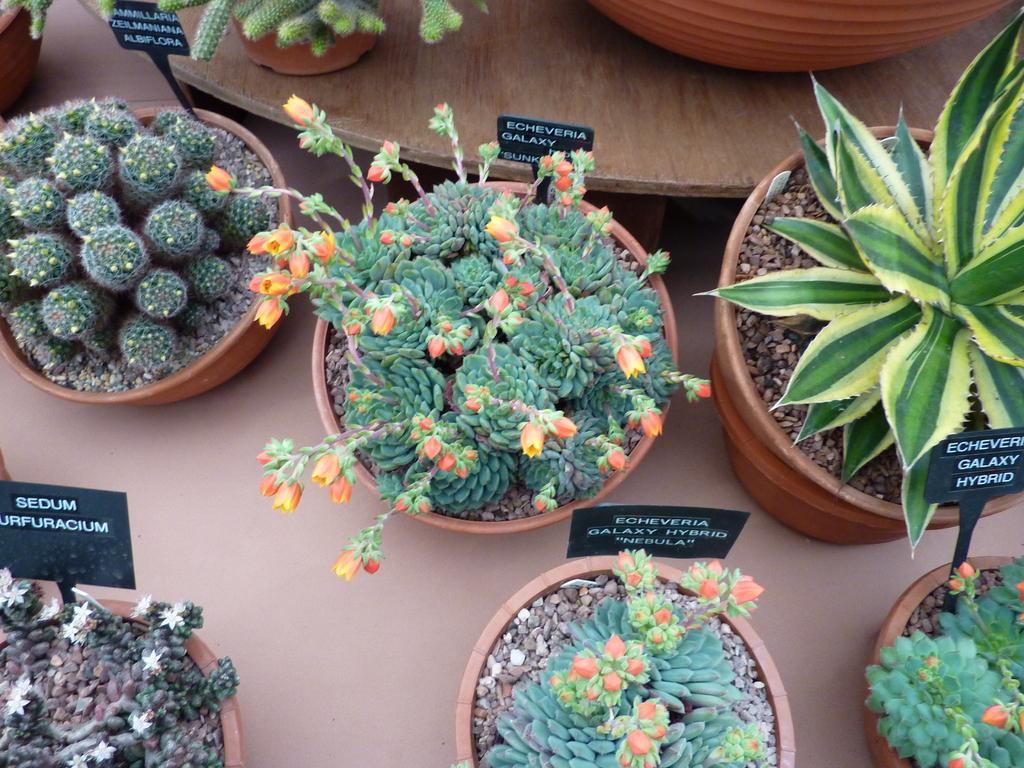In one or two sentences, can you explain what this image depicts? In this image there are some flower pots on the surface and on the wooden platform with names on it. 